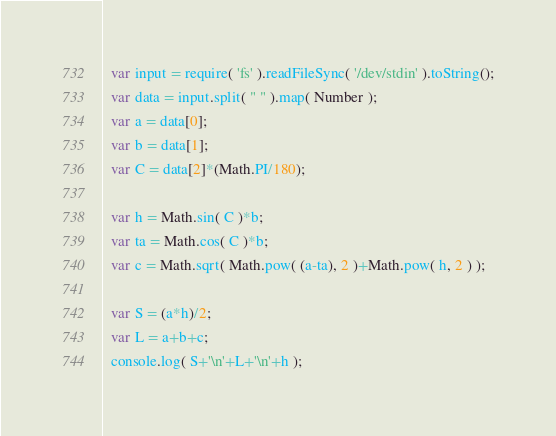<code> <loc_0><loc_0><loc_500><loc_500><_JavaScript_>  var input = require( 'fs' ).readFileSync( '/dev/stdin' ).toString();
  var data = input.split( " " ).map( Number );
  var a = data[0];
  var b = data[1];
  var C = data[2]*(Math.PI/180);
   
  var h = Math.sin( C )*b;
  var ta = Math.cos( C )*b;
  var c = Math.sqrt( Math.pow( (a-ta), 2 )+Math.pow( h, 2 ) );
   
  var S = (a*h)/2;
  var L = a+b+c;
  console.log( S+'\n'+L+'\n'+h );</code> 